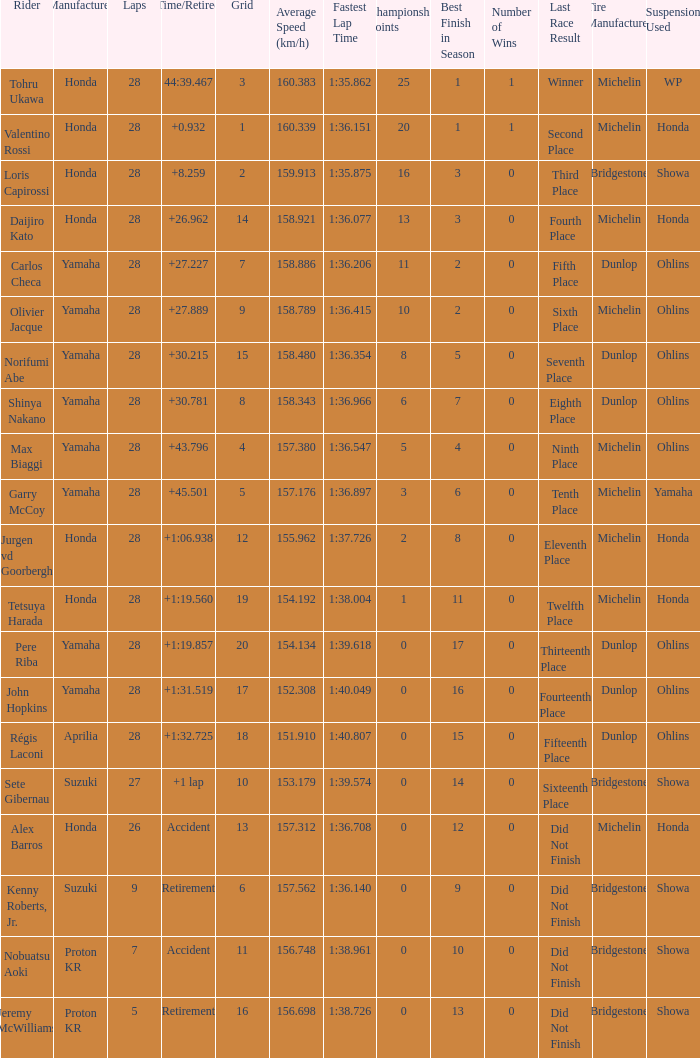Who manufactured grid 11? Proton KR. 